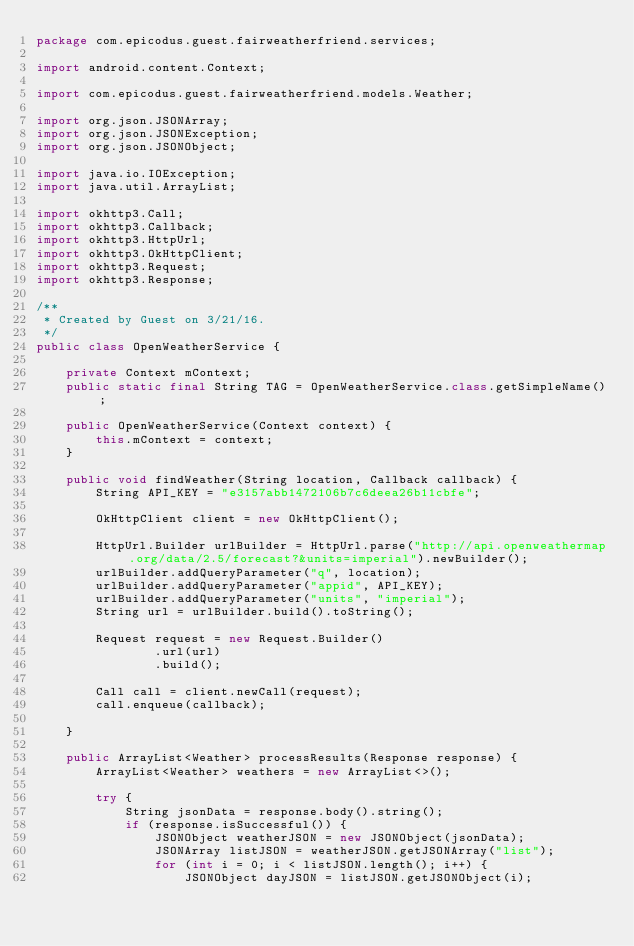Convert code to text. <code><loc_0><loc_0><loc_500><loc_500><_Java_>package com.epicodus.guest.fairweatherfriend.services;

import android.content.Context;

import com.epicodus.guest.fairweatherfriend.models.Weather;

import org.json.JSONArray;
import org.json.JSONException;
import org.json.JSONObject;

import java.io.IOException;
import java.util.ArrayList;

import okhttp3.Call;
import okhttp3.Callback;
import okhttp3.HttpUrl;
import okhttp3.OkHttpClient;
import okhttp3.Request;
import okhttp3.Response;

/**
 * Created by Guest on 3/21/16.
 */
public class OpenWeatherService {

    private Context mContext;
    public static final String TAG = OpenWeatherService.class.getSimpleName();

    public OpenWeatherService(Context context) {
        this.mContext = context;
    }

    public void findWeather(String location, Callback callback) {
        String API_KEY = "e3157abb1472106b7c6deea26b11cbfe";

        OkHttpClient client = new OkHttpClient();

        HttpUrl.Builder urlBuilder = HttpUrl.parse("http://api.openweathermap.org/data/2.5/forecast?&units=imperial").newBuilder();
        urlBuilder.addQueryParameter("q", location);
        urlBuilder.addQueryParameter("appid", API_KEY);
        urlBuilder.addQueryParameter("units", "imperial");
        String url = urlBuilder.build().toString();

        Request request = new Request.Builder()
                .url(url)
                .build();

        Call call = client.newCall(request);
        call.enqueue(callback);

    }

    public ArrayList<Weather> processResults(Response response) {
        ArrayList<Weather> weathers = new ArrayList<>();

        try {
            String jsonData = response.body().string();
            if (response.isSuccessful()) {
                JSONObject weatherJSON = new JSONObject(jsonData);
                JSONArray listJSON = weatherJSON.getJSONArray("list");
                for (int i = 0; i < listJSON.length(); i++) {
                    JSONObject dayJSON = listJSON.getJSONObject(i);</code> 